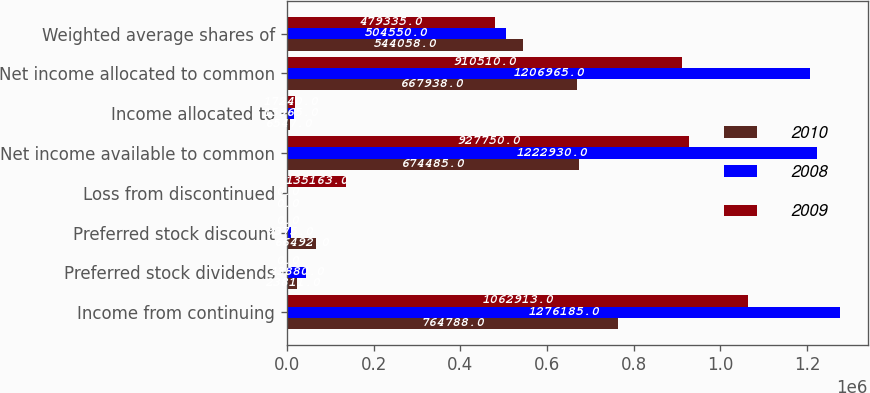<chart> <loc_0><loc_0><loc_500><loc_500><stacked_bar_chart><ecel><fcel>Income from continuing<fcel>Preferred stock dividends<fcel>Preferred stock discount<fcel>Loss from discontinued<fcel>Net income available to common<fcel>Income allocated to<fcel>Net income allocated to common<fcel>Weighted average shares of<nl><fcel>2010<fcel>764788<fcel>23811<fcel>66492<fcel>0<fcel>674485<fcel>6547<fcel>667938<fcel>544058<nl><fcel>2008<fcel>1.27618e+06<fcel>43880<fcel>9375<fcel>0<fcel>1.22293e+06<fcel>15965<fcel>1.20696e+06<fcel>504550<nl><fcel>2009<fcel>1.06291e+06<fcel>0<fcel>0<fcel>135163<fcel>927750<fcel>17240<fcel>910510<fcel>479335<nl></chart> 